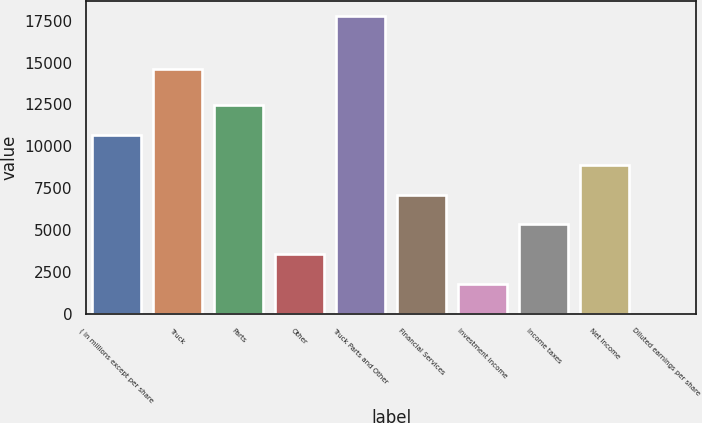Convert chart to OTSL. <chart><loc_0><loc_0><loc_500><loc_500><bar_chart><fcel>( in millions except per share<fcel>Truck<fcel>Parts<fcel>Other<fcel>Truck Parts and Other<fcel>Financial Services<fcel>Investment income<fcel>Income taxes<fcel>Net Income<fcel>Diluted earnings per share<nl><fcel>10677.2<fcel>14594<fcel>12456.1<fcel>3561.62<fcel>17792.8<fcel>7119.42<fcel>1782.72<fcel>5340.52<fcel>8898.32<fcel>3.82<nl></chart> 